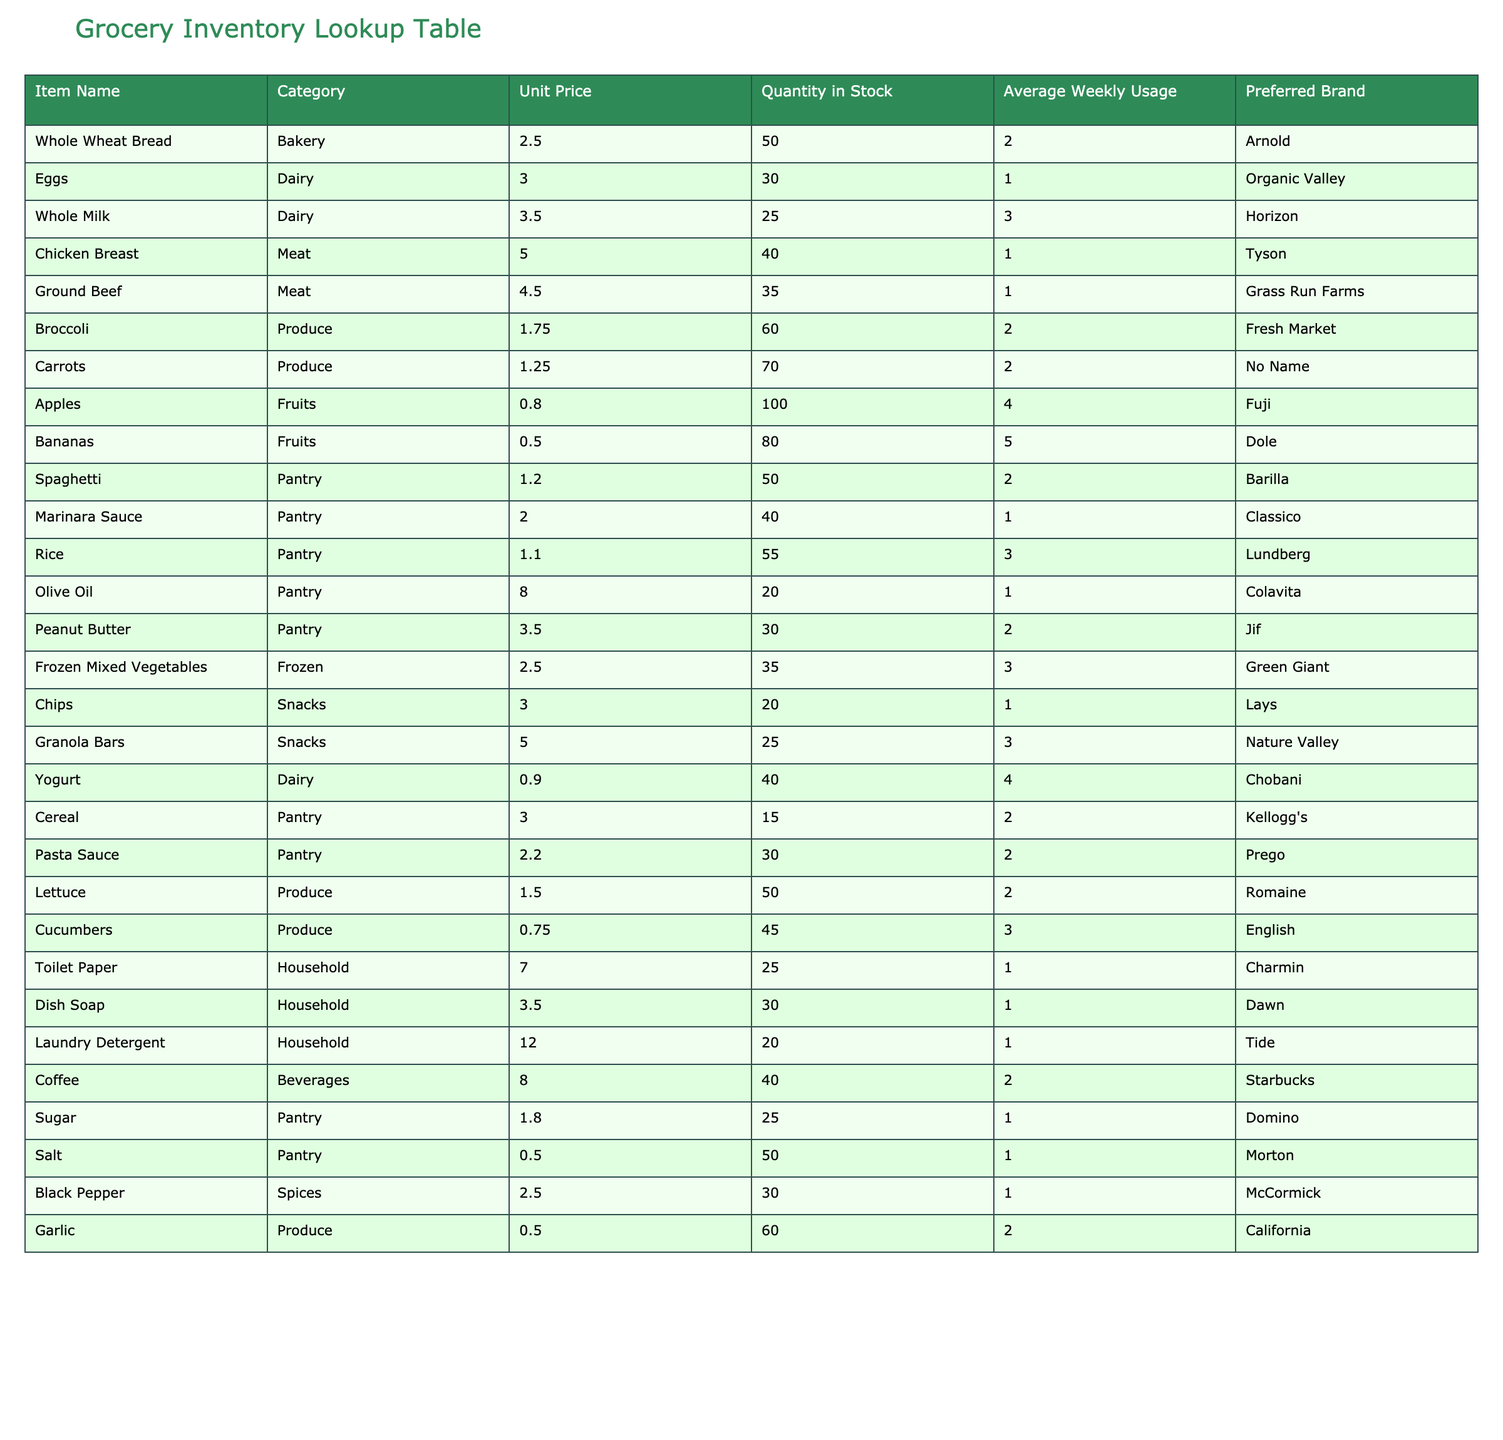What is the unit price of Whole Wheat Bread? The table lists Whole Wheat Bread under the Item Name column, and looking across the row, the corresponding Unit Price is found to be 2.50.
Answer: 2.50 How many units of Eggs are in stock? In the table, under the Item Name "Eggs," the Quantity in Stock column shows the value as 30.
Answer: 30 Which item has the highest unit price? The highest Unit Price can be found by examining the Unit Price column for all items. The highest value is 12.00, corresponding to Laundry Detergent.
Answer: Laundry Detergent Is there more than one dairy item in stock? Looking through the Dairy category in the table, we see Eggs (30), Whole Milk (25), and Yogurt (40). Since there are three dairy items, the answer is yes.
Answer: Yes What is the average quantity of stock for Fruits? The Fruits category includes Apples (100), Bananas (80). To find the average quantity, we sum the quantities (100 + 80 = 180) and divide by the number of items (2), resulting in 180 / 2 = 90.
Answer: 90 What is the total average weekly usage for all Produce items? We add up the average weekly usage for the Produce items: Broccoli (2), Carrots (2), Lettuce (2), Cucumbers (3), and Garlic (2). Summing these values gives us 2 + 2 + 2 + 3 + 2 = 11.
Answer: 11 Are there any items under the Snacks category that have a unit price greater than 4.00? Reviewing the Snacks category, Granola Bars have a unit price of 5.00, which is greater than 4.00. Therefore, the answer is yes.
Answer: Yes What is the difference in stock quantity between the highest and lowest stocked items? The highest stocked item is Apples with 100 units, and the lowest is Laundry Detergent with 20 units. The difference is calculated by subtracting 20 from 100, resulting in 100 - 20 = 80.
Answer: 80 How many different categories of items are present in the table? Counting the distinct categories listed in the table, we find Bakery, Dairy, Meat, Produce, Fruits, Pantry, Frozen, Snacks, Household, and Beverages, totaling 10 different categories.
Answer: 10 